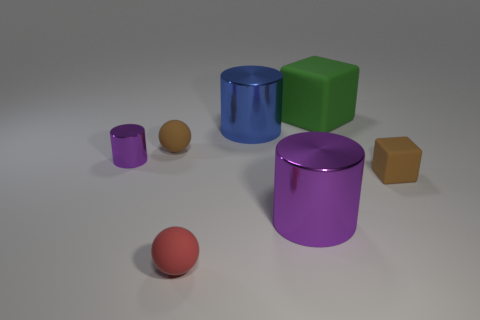Are there more tiny red objects behind the big blue shiny cylinder than green matte things?
Keep it short and to the point. No. What size is the matte thing that is both in front of the small shiny object and to the right of the blue metal cylinder?
Ensure brevity in your answer.  Small. There is another small thing that is the same shape as the small red matte thing; what material is it?
Provide a succinct answer. Rubber. Does the ball behind the red object have the same size as the big purple metal cylinder?
Your answer should be compact. No. The object that is both in front of the tiny cylinder and to the left of the blue object is what color?
Offer a terse response. Red. What number of metallic objects are behind the brown thing in front of the small brown rubber sphere?
Provide a succinct answer. 2. Do the small purple object and the large blue metallic thing have the same shape?
Give a very brief answer. Yes. Is there any other thing that is the same color as the large block?
Ensure brevity in your answer.  No. Does the tiny red object have the same shape as the brown object that is left of the big rubber thing?
Your answer should be compact. Yes. There is a big metallic cylinder that is behind the matte ball that is behind the tiny brown rubber thing that is right of the large green rubber thing; what color is it?
Make the answer very short. Blue. 